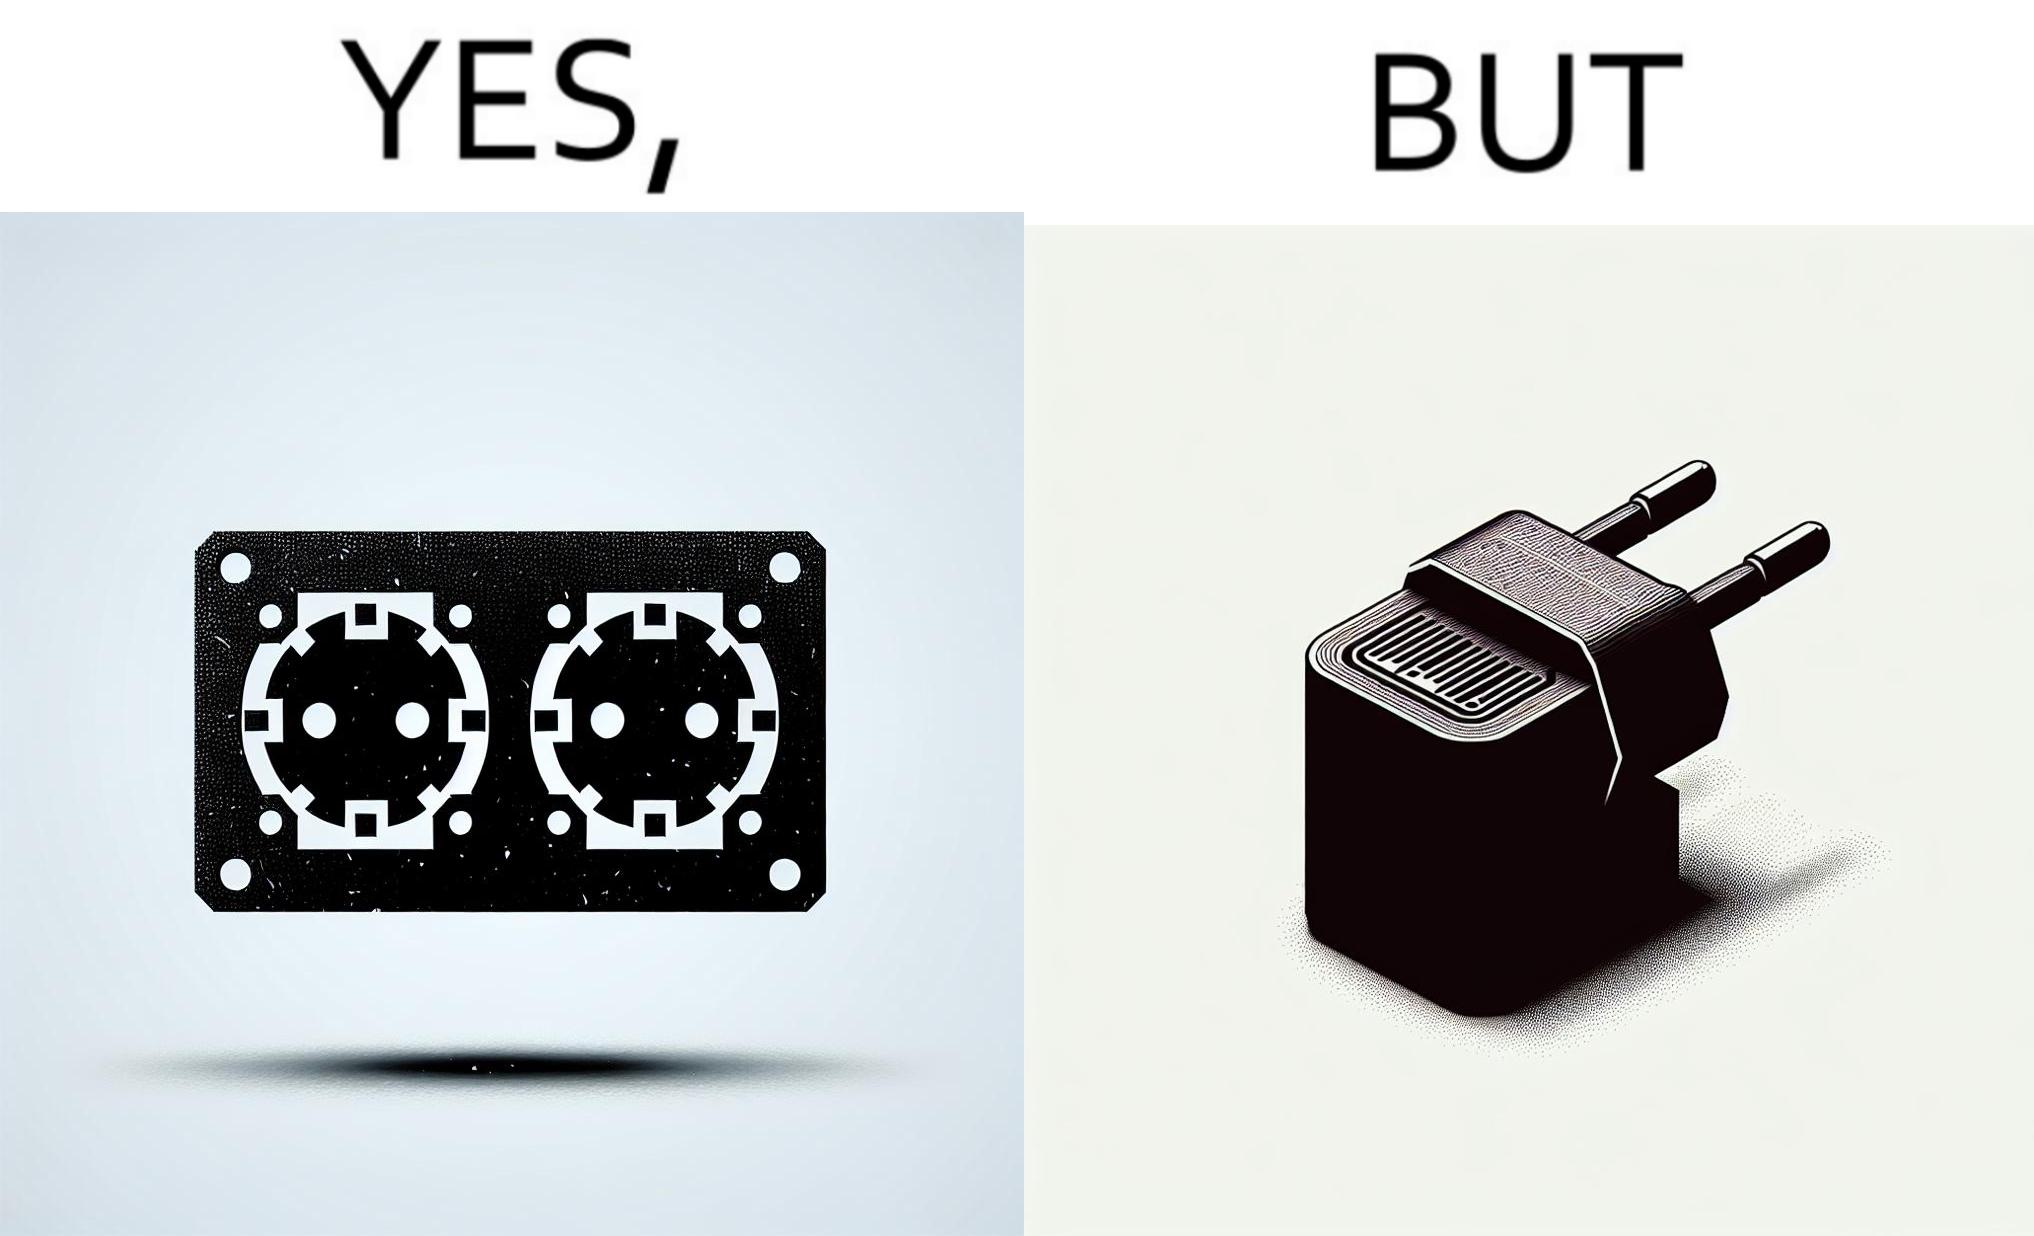What is shown in the left half versus the right half of this image? In the left part of the image: two electrical sockets side by side In the right part of the image: an electrical adapter 